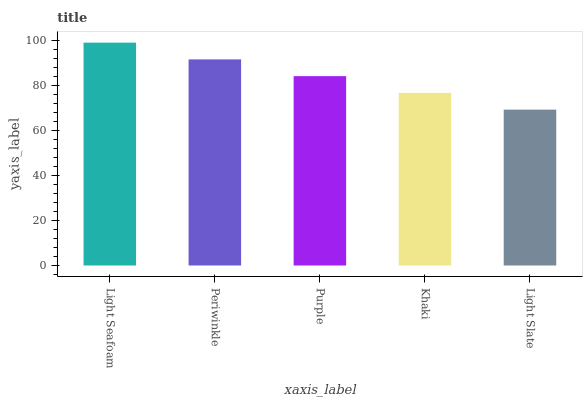Is Light Slate the minimum?
Answer yes or no. Yes. Is Light Seafoam the maximum?
Answer yes or no. Yes. Is Periwinkle the minimum?
Answer yes or no. No. Is Periwinkle the maximum?
Answer yes or no. No. Is Light Seafoam greater than Periwinkle?
Answer yes or no. Yes. Is Periwinkle less than Light Seafoam?
Answer yes or no. Yes. Is Periwinkle greater than Light Seafoam?
Answer yes or no. No. Is Light Seafoam less than Periwinkle?
Answer yes or no. No. Is Purple the high median?
Answer yes or no. Yes. Is Purple the low median?
Answer yes or no. Yes. Is Periwinkle the high median?
Answer yes or no. No. Is Light Seafoam the low median?
Answer yes or no. No. 